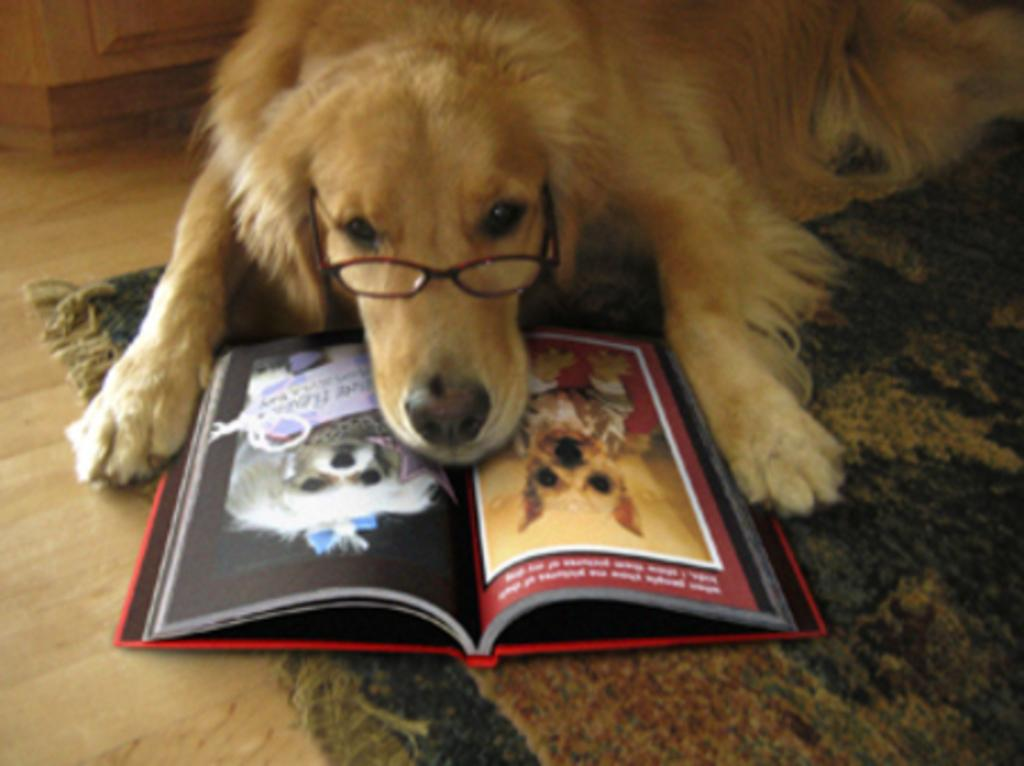What type of animal is in the image? There is a dog in the image. What is unique about the dog's appearance? The dog is wearing spectacles. What is the surface beneath the dog? There is a floor in the image. What is placed on the floor besides the dog? There is a mat and a book on the floor. What type of berry is the dog holding in its mouth in the image? There is no berry present in the image; the dog is wearing spectacles. 